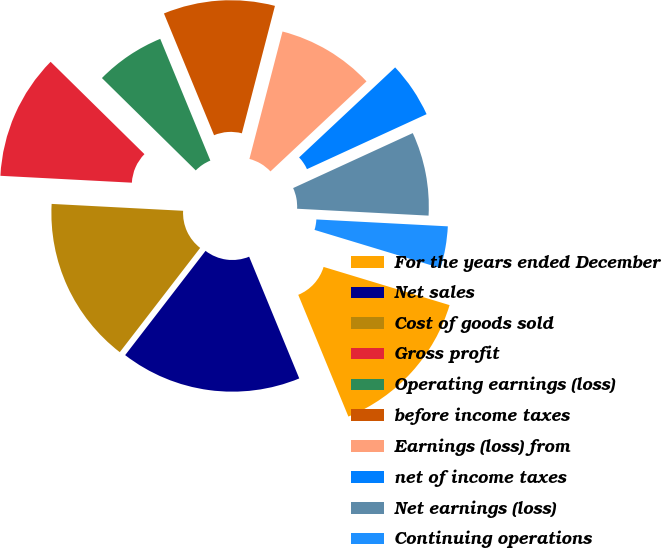<chart> <loc_0><loc_0><loc_500><loc_500><pie_chart><fcel>For the years ended December<fcel>Net sales<fcel>Cost of goods sold<fcel>Gross profit<fcel>Operating earnings (loss)<fcel>before income taxes<fcel>Earnings (loss) from<fcel>net of income taxes<fcel>Net earnings (loss)<fcel>Continuing operations<nl><fcel>14.1%<fcel>16.67%<fcel>15.38%<fcel>11.54%<fcel>6.41%<fcel>10.26%<fcel>8.97%<fcel>5.13%<fcel>7.69%<fcel>3.85%<nl></chart> 